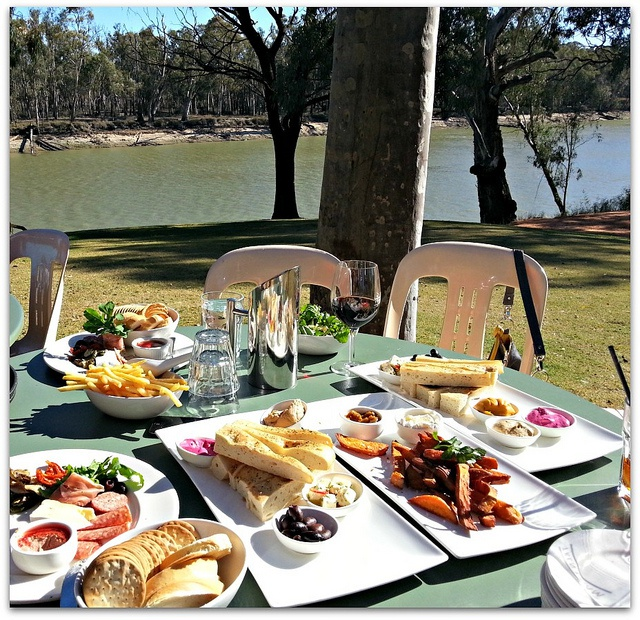Describe the objects in this image and their specific colors. I can see dining table in white, darkgray, black, and gray tones, chair in white, tan, gray, and black tones, chair in white, gray, black, and tan tones, sandwich in white, tan, khaki, gray, and lightyellow tones, and chair in white, gray, and tan tones in this image. 